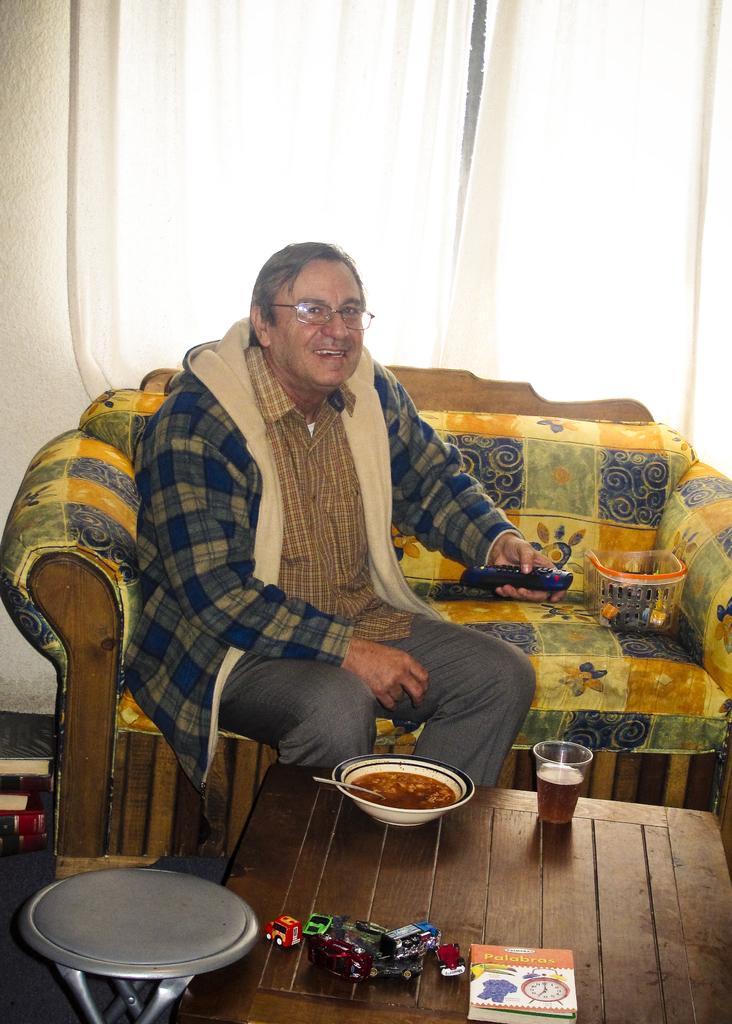Describe this image in one or two sentences. As we can see in the image there is man sitting on sofa. In front of man there is a table. On table there is a book, bowl and glass. 